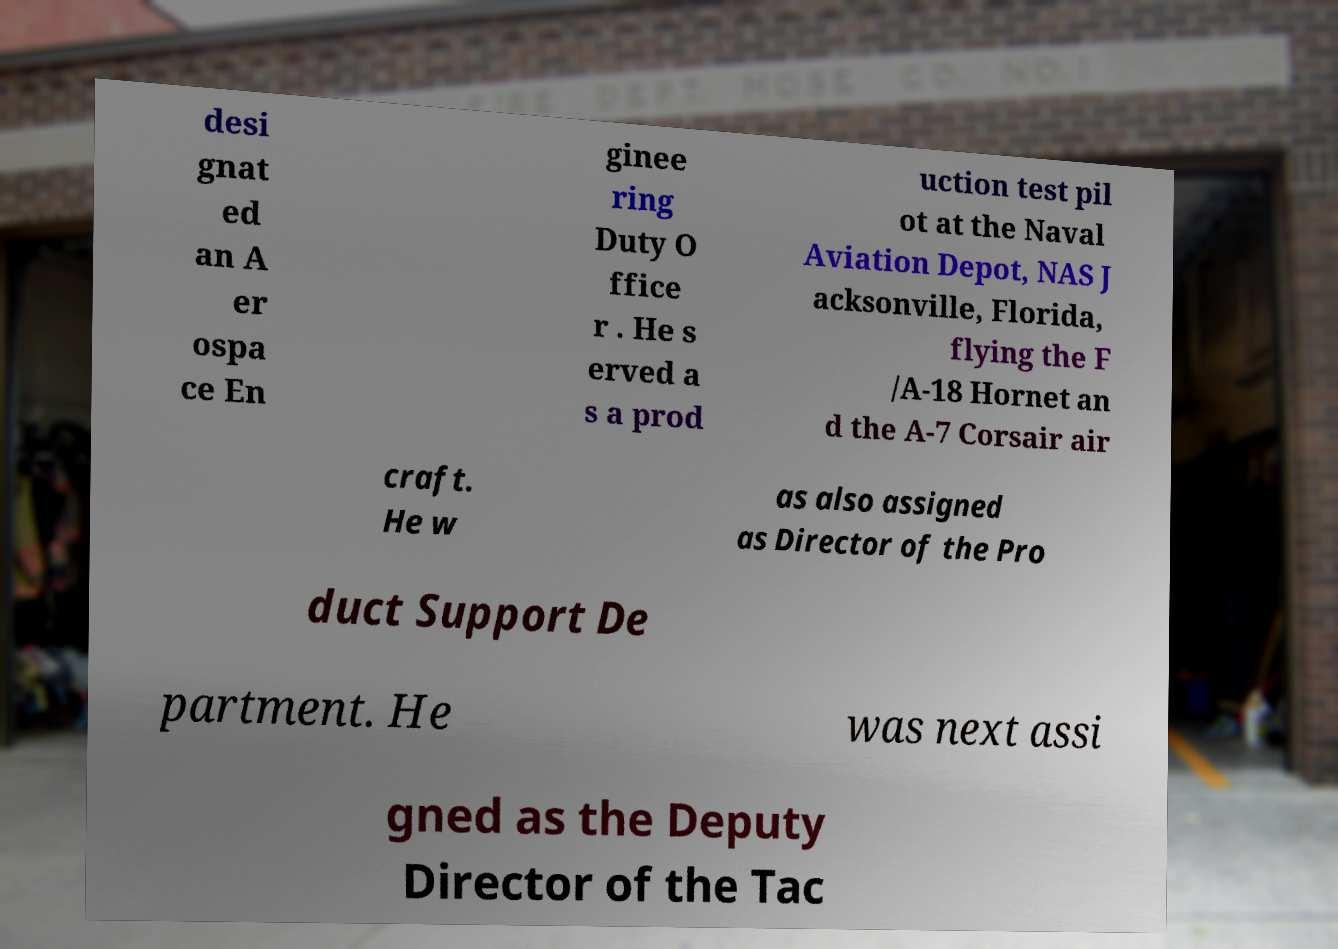I need the written content from this picture converted into text. Can you do that? desi gnat ed an A er ospa ce En ginee ring Duty O ffice r . He s erved a s a prod uction test pil ot at the Naval Aviation Depot, NAS J acksonville, Florida, flying the F /A-18 Hornet an d the A-7 Corsair air craft. He w as also assigned as Director of the Pro duct Support De partment. He was next assi gned as the Deputy Director of the Tac 